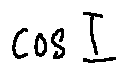Convert formula to latex. <formula><loc_0><loc_0><loc_500><loc_500>\cos I</formula> 